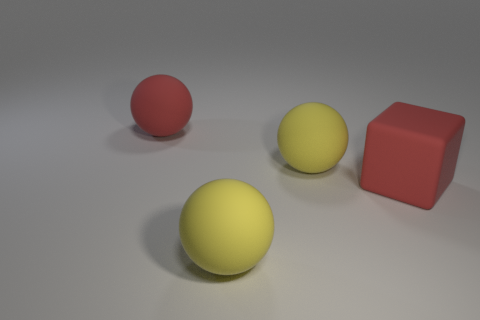What is the size of the cube that is in front of the large red rubber object that is to the left of the red cube?
Your answer should be very brief. Large. There is a matte object that is behind the big rubber block and to the right of the red ball; what is its color?
Provide a succinct answer. Yellow. How many small objects are cyan matte objects or balls?
Provide a short and direct response. 0. The block that is the same material as the red sphere is what color?
Keep it short and to the point. Red. The block right of the big red rubber sphere is what color?
Keep it short and to the point. Red. What number of other large cubes have the same color as the cube?
Ensure brevity in your answer.  0. Are there fewer large rubber blocks that are right of the rubber cube than big yellow matte objects right of the big red rubber ball?
Offer a very short reply. Yes. There is a red matte cube; what number of large yellow balls are left of it?
Your response must be concise. 2. Is there a red thing that has the same material as the red cube?
Ensure brevity in your answer.  Yes. Are there more large yellow spheres in front of the large red matte ball than big red rubber blocks that are behind the large red rubber block?
Your response must be concise. Yes. 